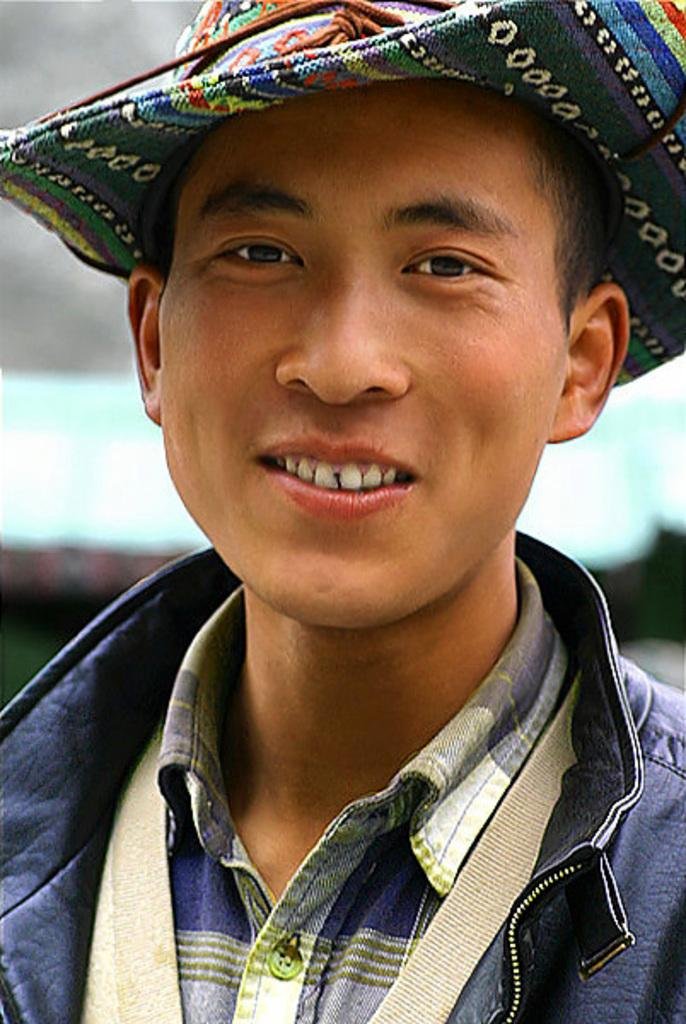Who is in the picture? There is a man in the picture. What is the man doing in the picture? The man is standing in the picture. What expression does the man have on his face? The man is smiling in the picture. What accessories is the man wearing in the picture? The man is wearing a hat on his head and a jacket in the picture. What type of flesh can be seen on the man's arm in the image? There is no flesh visible on the man's arm in the image; he is fully clothed in a jacket. 